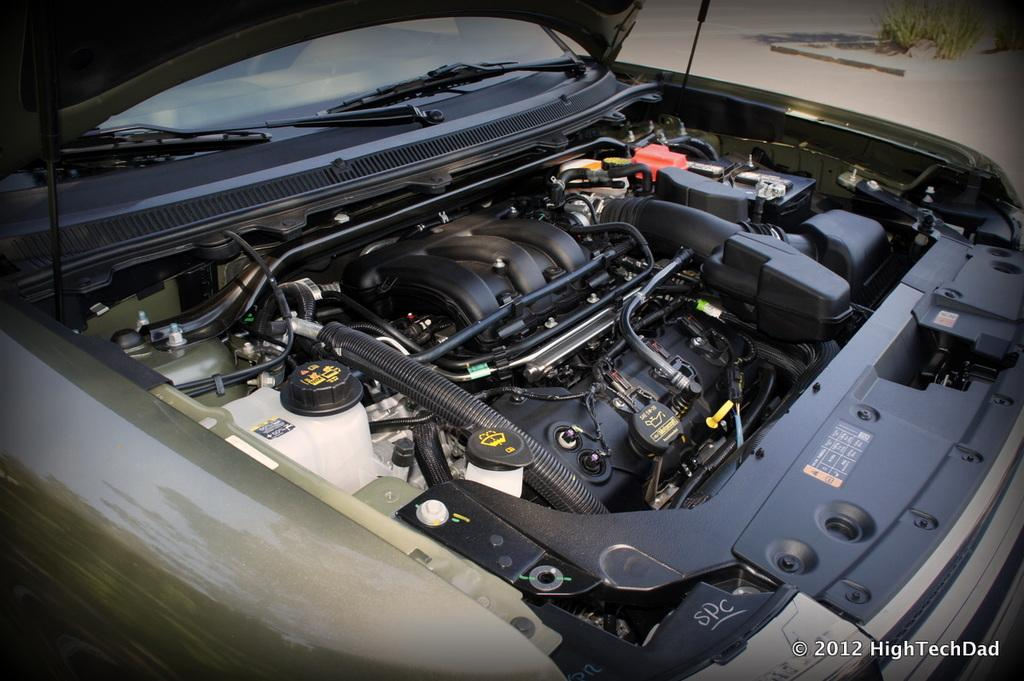What is the main subject of the image? The main subject of the image is the engine of a vehicle. Can you describe any specific components or objects within the engine? There are a few objects present in the engine, but their specific details are not mentioned in the provided facts. How many jellyfish can be seen swimming in the engine of the vehicle in the image? There are no jellyfish present in the image; it features an engine of a vehicle. What type of pie is being served in the engine of the vehicle in the image? There is no pie present in the image; it features an engine of a vehicle. 